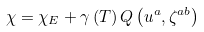<formula> <loc_0><loc_0><loc_500><loc_500>\chi = \chi _ { E } + \gamma \left ( T \right ) Q \left ( u ^ { a } , \zeta ^ { a b } \right )</formula> 